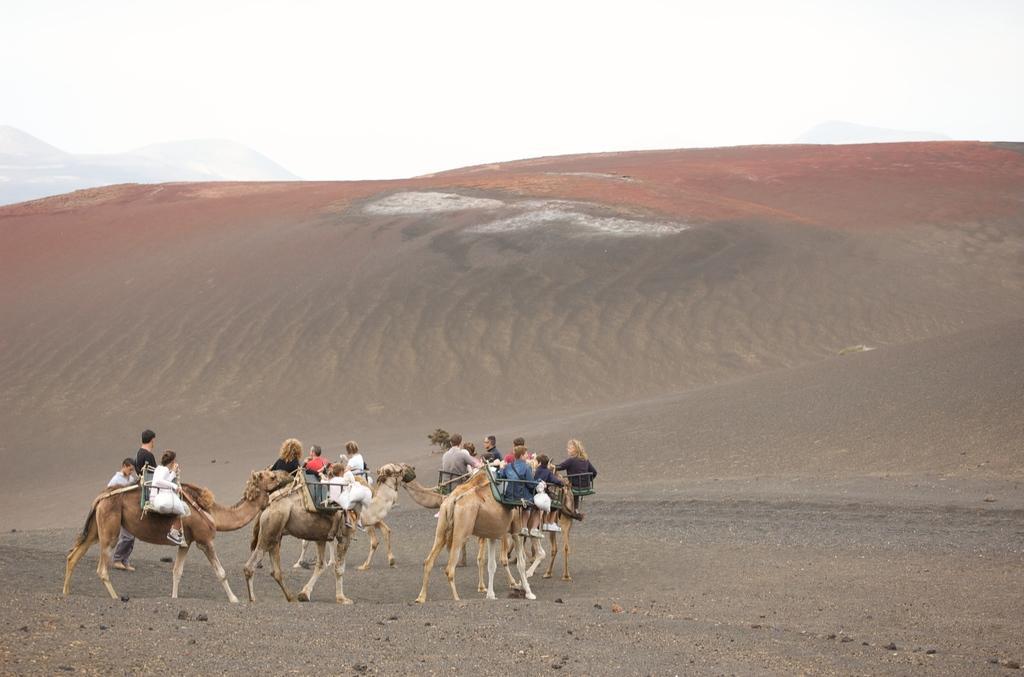Please provide a concise description of this image. In this picture I can see a group of people sitting on camels. Behind the person we can see the desert. At the top we can see the sky. 